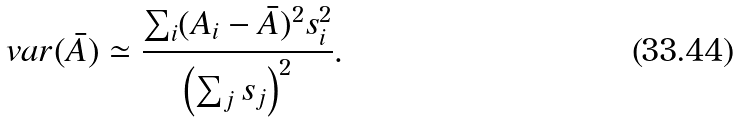Convert formula to latex. <formula><loc_0><loc_0><loc_500><loc_500>v a r ( \bar { A } ) \simeq \frac { \sum _ { i } ( A _ { i } - \bar { A } ) ^ { 2 } s _ { i } ^ { 2 } } { \left ( \sum _ { j } s _ { j } \right ) ^ { 2 } } .</formula> 